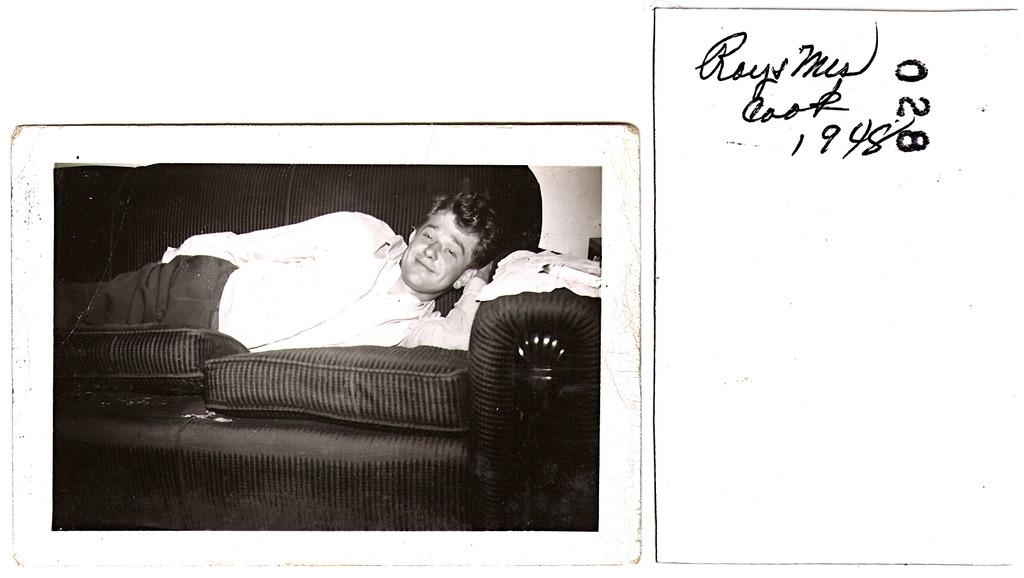What is present on the paper in the image? The paper has text on it. Where is the couch located in the image? The couch is in the bottom left corner of the image. What is the person on the couch doing? The person is lying on the couch and smiling. How many spiders are crawling on the person in the image? There are no spiders present in the image. What type of animals can be seen at the zoo in the image? There is no zoo present in the image. 